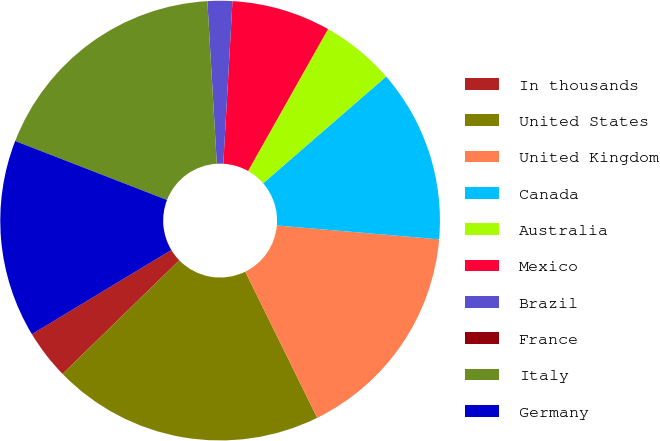Convert chart. <chart><loc_0><loc_0><loc_500><loc_500><pie_chart><fcel>In thousands<fcel>United States<fcel>United Kingdom<fcel>Canada<fcel>Australia<fcel>Mexico<fcel>Brazil<fcel>France<fcel>Italy<fcel>Germany<nl><fcel>3.64%<fcel>20.0%<fcel>16.36%<fcel>12.73%<fcel>5.46%<fcel>7.27%<fcel>1.82%<fcel>0.0%<fcel>18.18%<fcel>14.54%<nl></chart> 